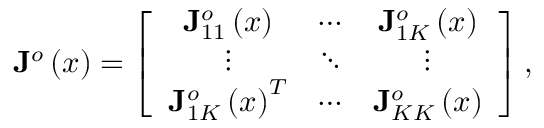Convert formula to latex. <formula><loc_0><loc_0><loc_500><loc_500>J ^ { o } \left ( x \right ) = \left [ \begin{array} { c c c } { J _ { 1 1 } ^ { o } \left ( x \right ) } & { \cdots } & { J _ { 1 K } ^ { o } \left ( x \right ) } \\ { \vdots } & { \ddots } & { \vdots } \\ { J _ { 1 K } ^ { o } \left ( x \right ) ^ { T } } & { \cdots } & { J _ { K K } ^ { o } \left ( x \right ) } \end{array} \right ] ,</formula> 